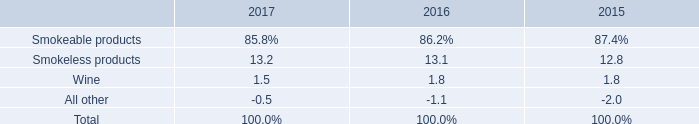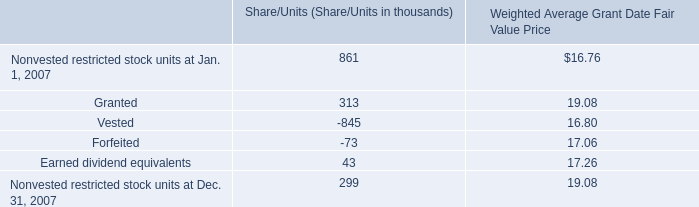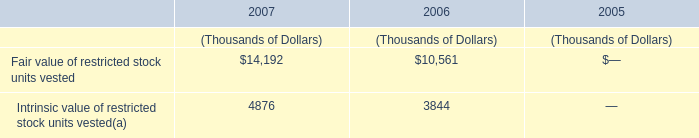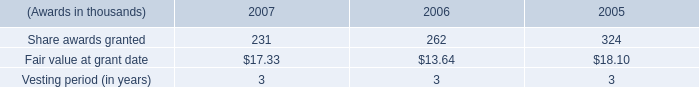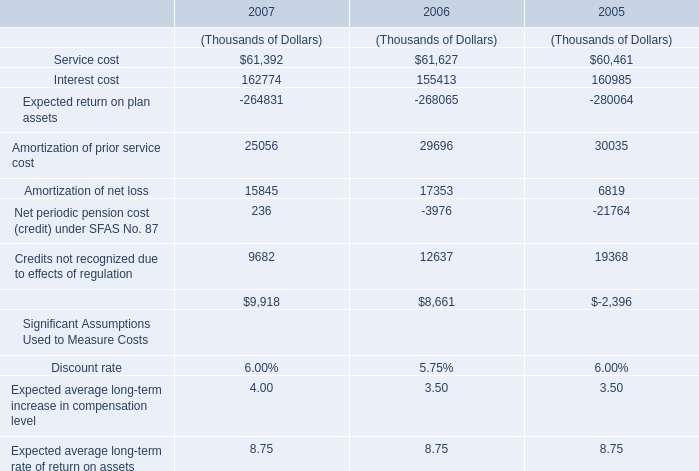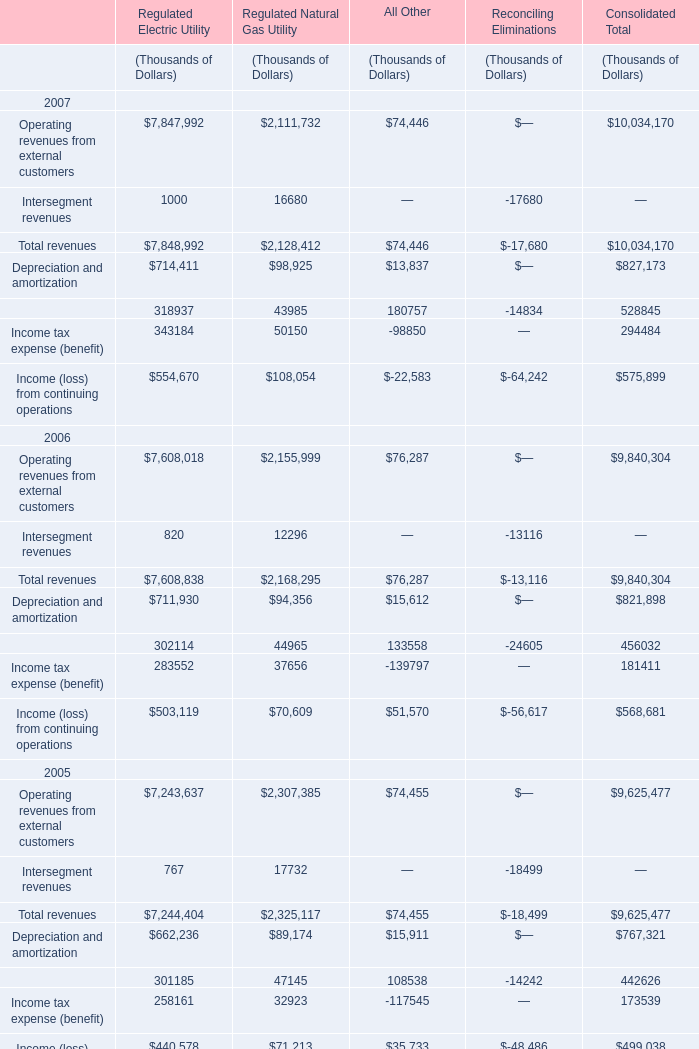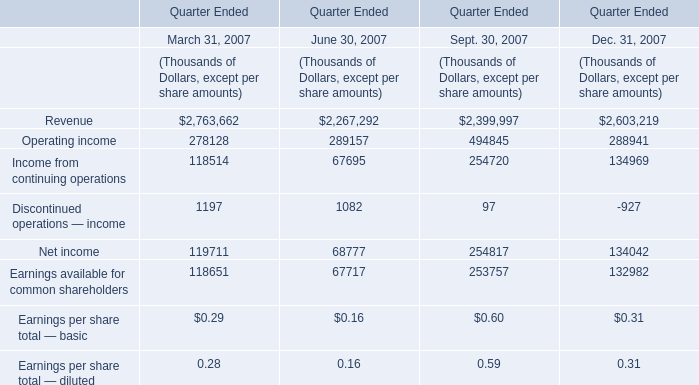Which element for Sept. 30, 2007 makes up more than 10% of the total in 2007? 
Answer: Revenue,Operating income. 